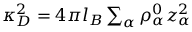<formula> <loc_0><loc_0><loc_500><loc_500>\begin{array} { r } { \kappa _ { D } ^ { 2 } = 4 \pi l _ { B } \sum _ { \alpha } \rho _ { \alpha } ^ { 0 } z _ { \alpha } ^ { 2 } } \end{array}</formula> 